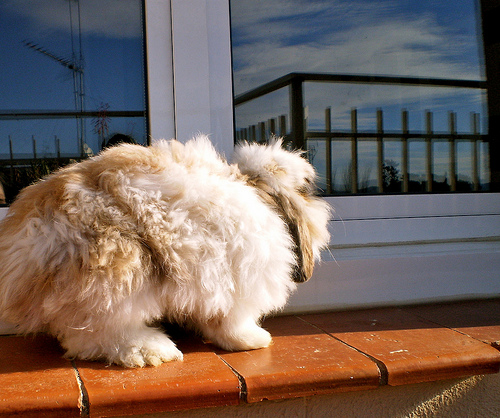<image>
Is the dog behind the window? No. The dog is not behind the window. From this viewpoint, the dog appears to be positioned elsewhere in the scene. 